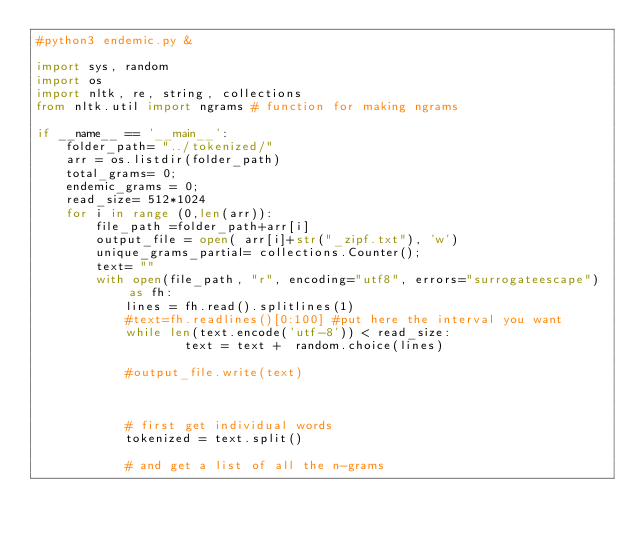<code> <loc_0><loc_0><loc_500><loc_500><_Python_>#python3 endemic.py &

import sys, random
import os
import nltk, re, string, collections
from nltk.util import ngrams # function for making ngrams

if __name__ == '__main__':
    folder_path= "../tokenized/"
    arr = os.listdir(folder_path)
    total_grams= 0;
    endemic_grams = 0;
    read_size= 512*1024
    for i in range (0,len(arr)):
        file_path =folder_path+arr[i] 
        output_file = open( arr[i]+str("_zipf.txt"), 'w')
        unique_grams_partial= collections.Counter();
        text= ""
        with open(file_path, "r", encoding="utf8", errors="surrogateescape") as fh:
            lines = fh.read().splitlines(1)
            #text=fh.readlines()[0:100] #put here the interval you want
            while len(text.encode('utf-8')) < read_size:
                    text = text +  random.choice(lines)

            #output_file.write(text)


            
            # first get individual words
            tokenized = text.split()

            # and get a list of all the n-grams</code> 